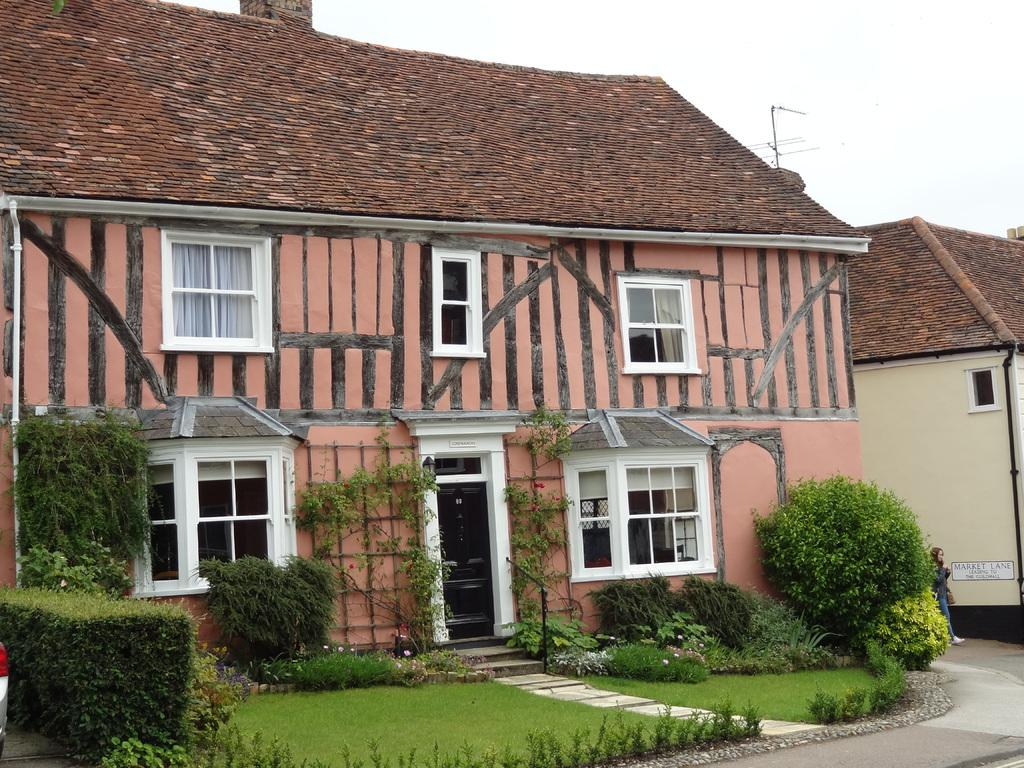What type of living organisms can be seen in the image? Plants can be seen in the image. What structure is located in the middle of the image? There is a shelter house in the middle of the image. What is visible at the top of the image? The sky is visible at the top of the image. What type of wire is used to hold the dinner in the image? There is no wire or dinner present in the image. What type of cannon is visible in the image? There is no cannon present in the image. 